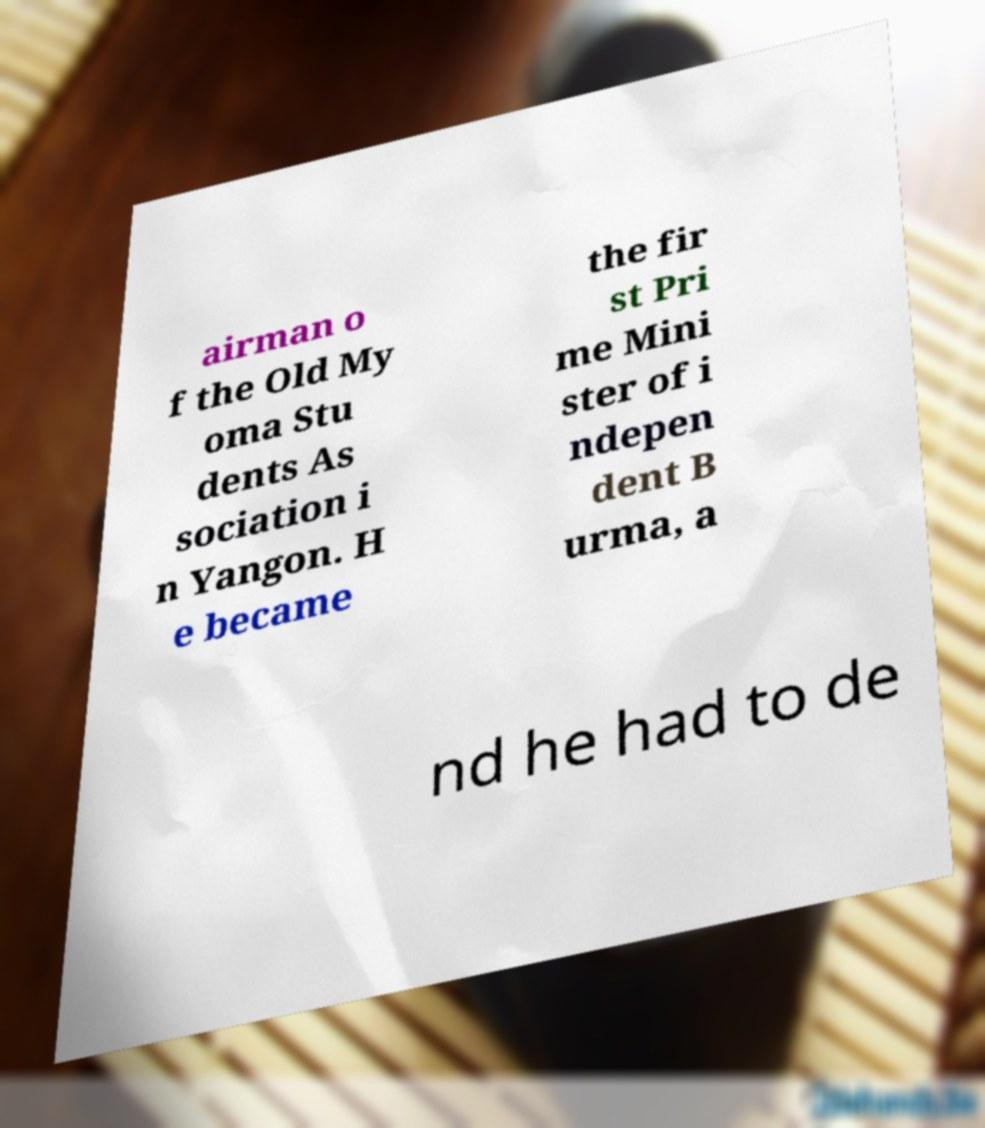Could you assist in decoding the text presented in this image and type it out clearly? airman o f the Old My oma Stu dents As sociation i n Yangon. H e became the fir st Pri me Mini ster of i ndepen dent B urma, a nd he had to de 